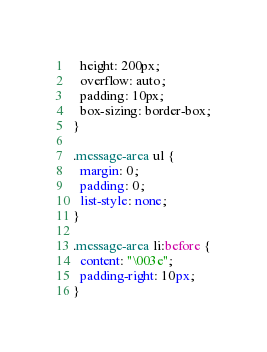<code> <loc_0><loc_0><loc_500><loc_500><_CSS_>  height: 200px;
  overflow: auto;
  padding: 10px;
  box-sizing: border-box;
}

.message-area ul {
  margin: 0;
  padding: 0;
  list-style: none;
}

.message-area li:before {
  content: "\003e";
  padding-right: 10px;
}
</code> 